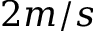Convert formula to latex. <formula><loc_0><loc_0><loc_500><loc_500>2 m / s</formula> 